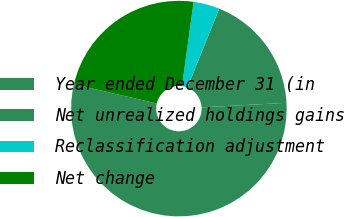<chart> <loc_0><loc_0><loc_500><loc_500><pie_chart><fcel>Year ended December 31 (in<fcel>Net unrealized holdings gains<fcel>Reclassification adjustment<fcel>Net change<nl><fcel>54.48%<fcel>18.04%<fcel>3.92%<fcel>23.56%<nl></chart> 